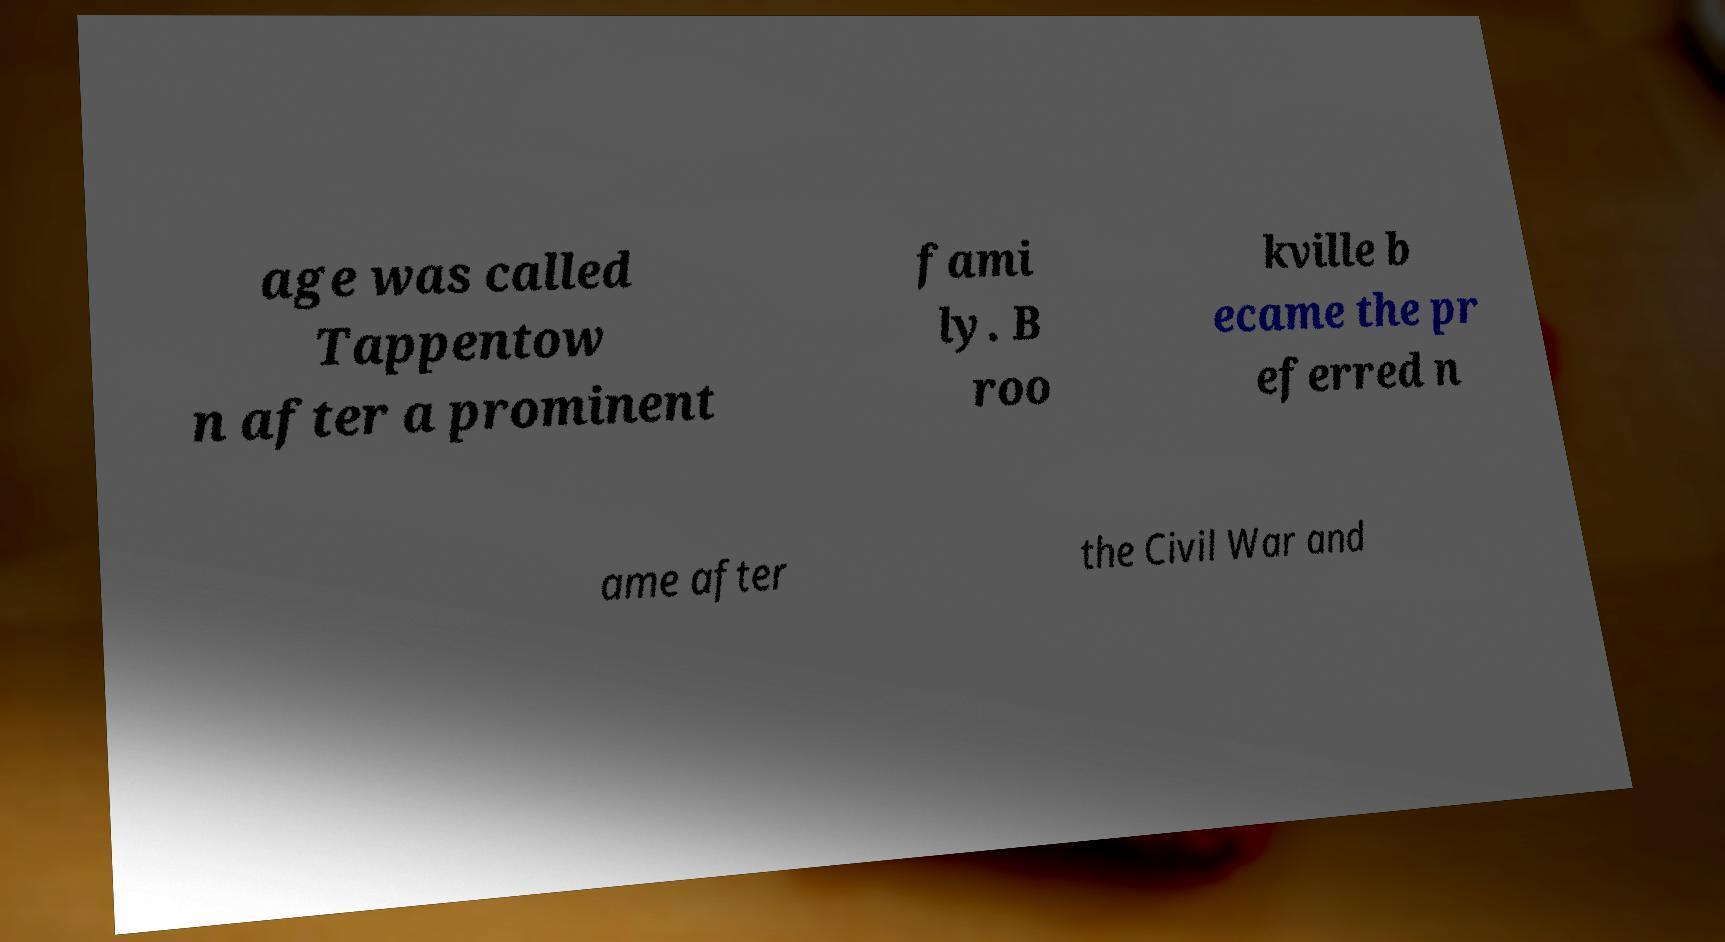Could you assist in decoding the text presented in this image and type it out clearly? age was called Tappentow n after a prominent fami ly. B roo kville b ecame the pr eferred n ame after the Civil War and 